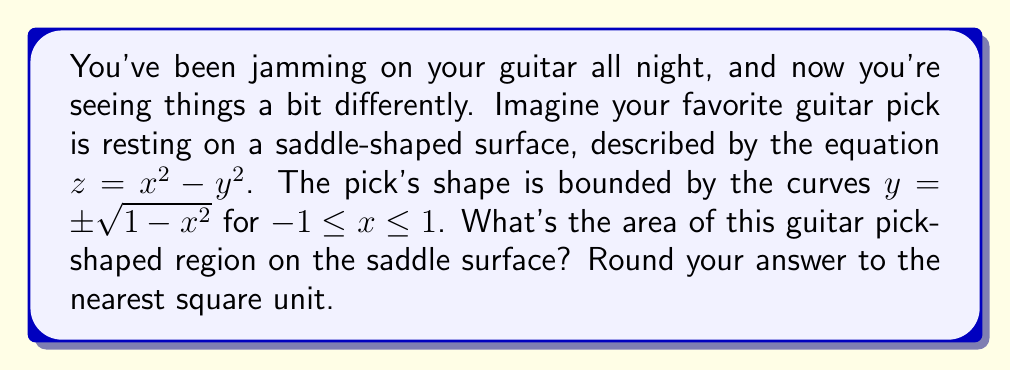Can you answer this question? Let's break this down step-by-step:

1) The area of a surface in 3D space is given by the surface integral:

   $$ A = \iint_R \sqrt{1 + (\frac{\partial z}{\partial x})^2 + (\frac{\partial z}{\partial y})^2} \, dA $$

2) For our saddle surface $z = x^2 - y^2$, we have:
   $\frac{\partial z}{\partial x} = 2x$ and $\frac{\partial z}{\partial y} = -2y$

3) Substituting these into our area formula:

   $$ A = \iint_R \sqrt{1 + (2x)^2 + (-2y)^2} \, dA $$
   $$ A = \iint_R \sqrt{1 + 4x^2 + 4y^2} \, dA $$

4) Our region R is bounded by $y = \pm \sqrt{1-x^2}$ for $-1 \leq x \leq 1$. This suggests using polar coordinates:
   $x = r\cos\theta$, $y = r\sin\theta$

5) The boundary $y = \pm \sqrt{1-x^2}$ becomes $r = 1$ in polar coordinates.

6) Our integral becomes:

   $$ A = \int_0^{2\pi} \int_0^1 \sqrt{1 + 4r^2\cos^2\theta + 4r^2\sin^2\theta} \, r \, dr \, d\theta $$
   $$ A = \int_0^{2\pi} \int_0^1 \sqrt{1 + 4r^2} \, r \, dr \, d\theta $$

7) Evaluating the inner integral:

   $$ A = \int_0^{2\pi} [\frac{1}{8}((1+4r^2)^{3/2} - 1)]_0^1 \, d\theta $$
   $$ A = \int_0^{2\pi} \frac{1}{8}(5^{3/2} - 1) \, d\theta $$

8) Evaluating the outer integral:

   $$ A = 2\pi \cdot \frac{1}{8}(5^{3/2} - 1) $$
   $$ A = \frac{\pi}{4}(5^{3/2} - 1) $$

9) Evaluating and rounding to the nearest square unit:

   $$ A \approx 8.64 \approx 9 $$
Answer: 9 square units 